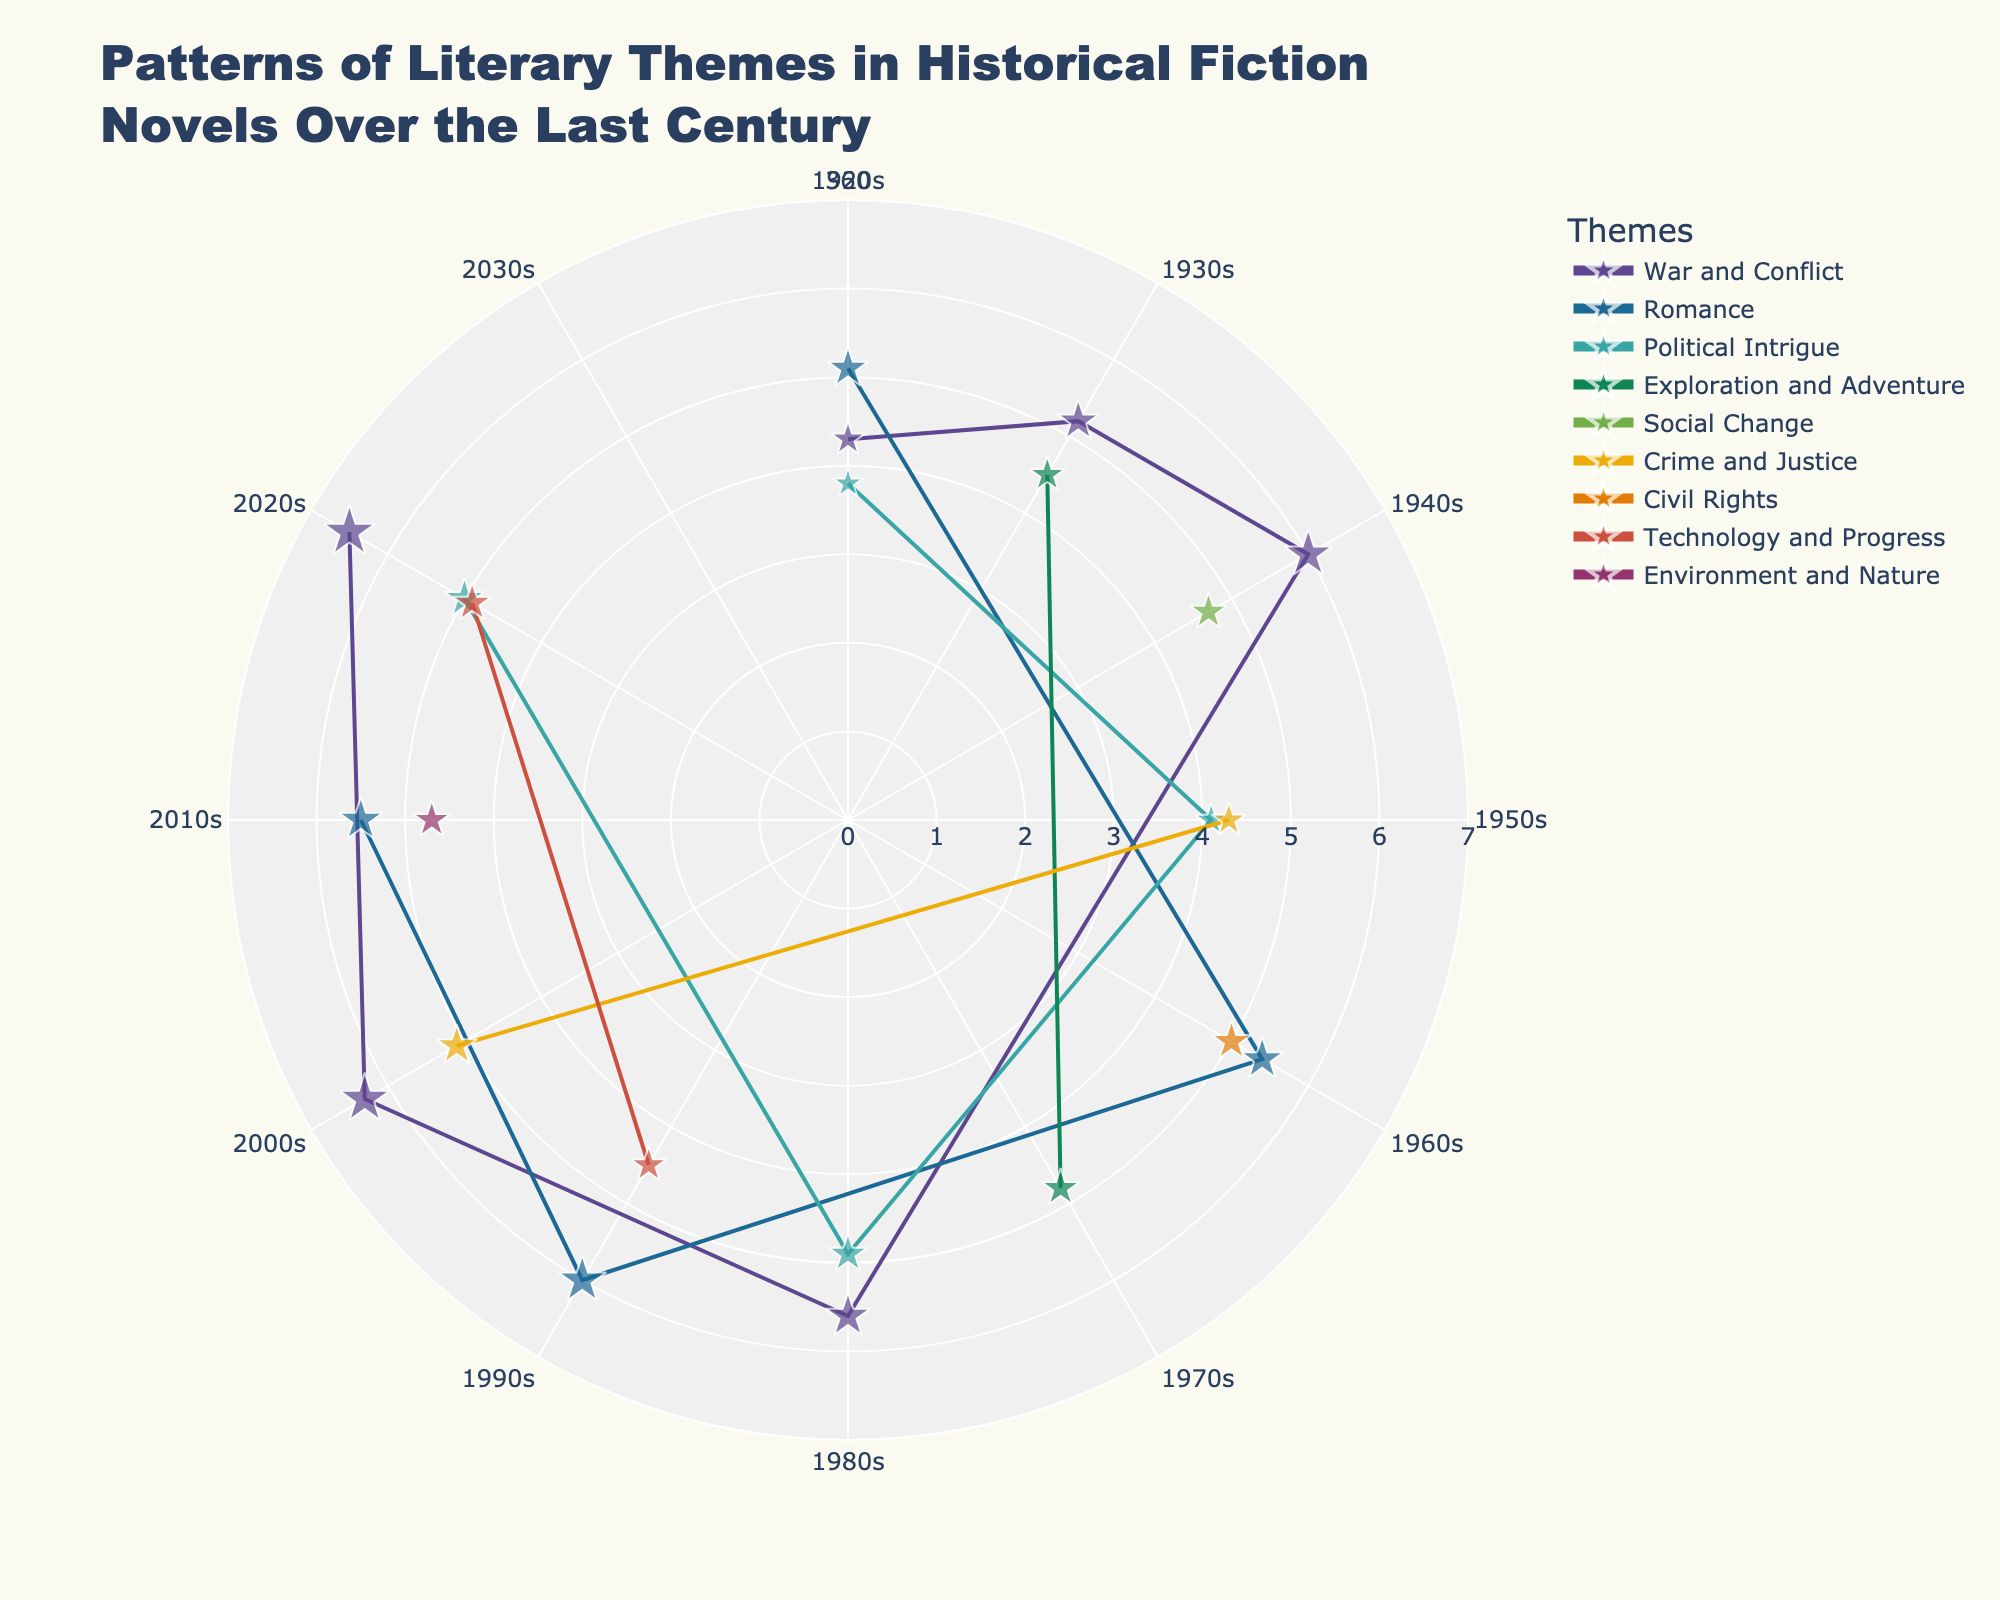What is the title of the plot? The title can be found at the top of the plot. It reads: "Patterns of Literary Themes in Historical Fiction Novels Over the Last Century"
Answer: Patterns of Literary Themes in Historical Fiction Novels Over the Last Century Which theme shows the highest popularity in the 2020s? By looking at the markers for the 2020s, we can identify the theme with the highest `r` value. "War and Conflict" theme is the highest in the 2020s at 6.5.
Answer: War and Conflict What is the average popularity of the "War and Conflict" theme across all decades? The popularity values for "War and Conflict" are 4.3 (1920s), 5.2 (1930s), 6.0 (1940s), 5.6 (1980s), 6.3 (2000s), and 6.5 (2020s). The average is calculated as (4.3 + 5.2 + 6.0 + 5.6 + 6.3 + 6.5) / 6 ≈ 5.65.
Answer: 5.65 Which decade shows the highest popularity for the theme "Romance"? Looking at the 'Romance' markers for each decade, the highest `r` value for "Romance" is in the 1990s at 6.0.
Answer: 1990s How does the popularity of "Political Intrigue" in the 2020s compare to the 1980s? By comparing the markers for "Political Intrigue" in both decades, we find the value in the 1980s is 4.9, and in the 2020s is 5.0. Thus, the popularity has slightly increased.
Answer: Slightly increased What is the combined popularity of "Crime and Justice" in the 1950s and 2000s? The popularity for "Crime and Justice" is 4.3 in the 1950s and 5.1 in the 2000s. The combined popularity is 4.3 + 5.1 = 9.4.
Answer: 9.4 Which theme has the least variation in popularity over the decades? Checking the range of popularity values for each theme, "Technology and Progress" has values of 4.5 and 4.9 over two decades, showing the smallest range of 0.4.
Answer: Technology and Progress What can you say about the popularity trends of "Social Change" and "Civil Rights"? "Social Change" appears only in the 1940s with a popularity value of 4.7, and "Civil Rights" appears only in the 1960s with a popularity value of 5.0. Both themes show significant but isolated popularity.
Answer: Isolated but significant popularity Which decade first introduced environmental themes in historical fiction according to the chart? Searching for the environmental theme, we see "Environment and Nature" first appears in the 2010s.
Answer: 2010s How does the theme "Exploration and Adventure" fare over the decades shown? The theme "Exploration and Adventure" appears in the 1930s with a 4.5 and in the 1970s with a 4.8, indicating a slight increase in popularity over time.
Answer: Slight increase 